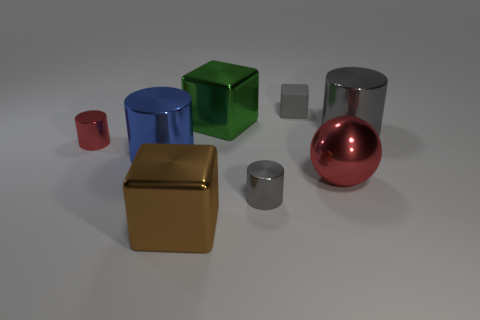What textures do the objects in the image appear to have? The image showcases various textures among the objects. The cylinders and sphere appear smooth and polished, indicating a possible metallic or plastic material. The cubes have a matte finish, with the green cube looking like it could be made of a matte plastic or painted wood, while the gold-colored cube seems to have a metallic or foil-like texture. The grey block is semi-transparent with a smooth texture, suggesting a material like frosted glass or clear plastic. 